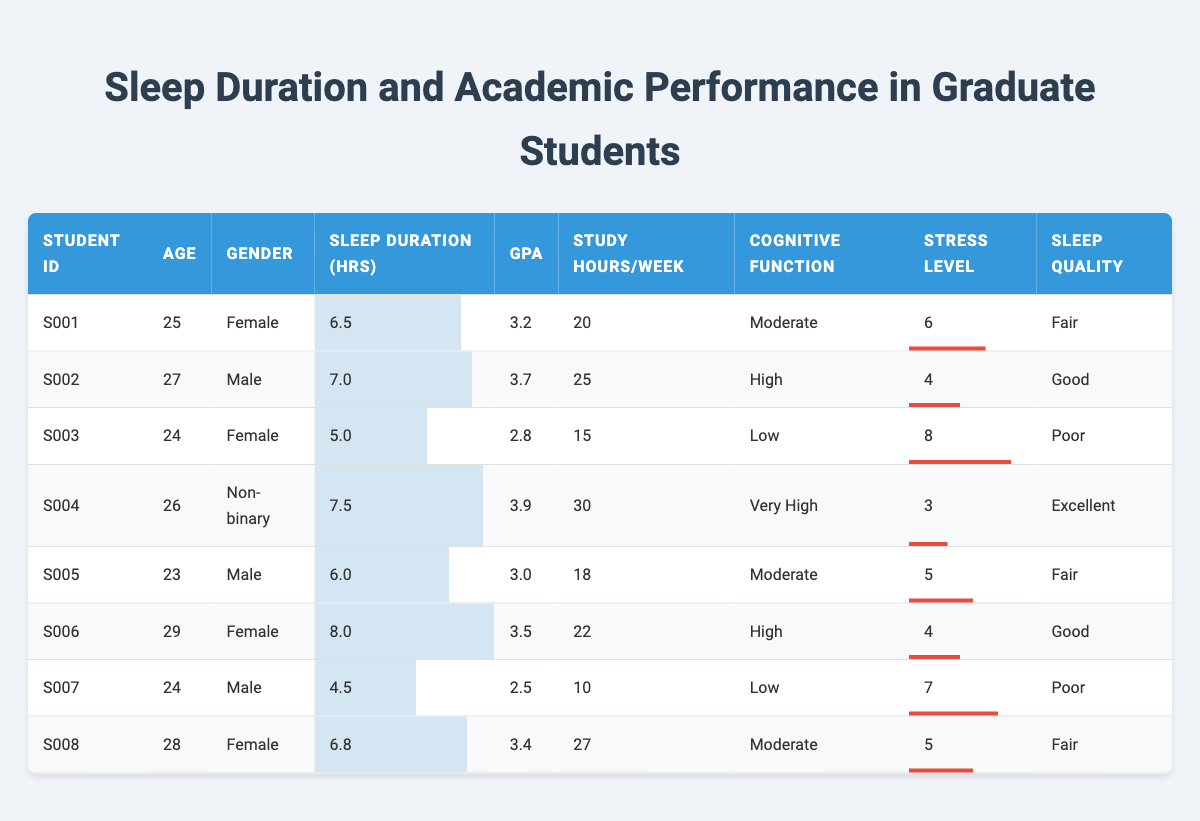What is the GPA of the student with the highest average sleep duration? The student with the highest average sleep duration is S006, who sleeps 8.0 hours and has a GPA of 3.5.
Answer: 3.5 How many students have a GPA above 3.5? The students with a GPA above 3.5 are S002, S004, and S006, totaling 3 students.
Answer: 3 What is the average age of all students in the table? The total ages of all students are 25 + 27 + 24 + 26 + 23 + 29 + 24 + 28 = 206. There are 8 students, so the average age is 206/8 = 25.75.
Answer: 25.75 Is there a student who sleeps less than 5 hours on average? Yes, student S007 sleeps an average of 4.5 hours, which is less than 5 hours.
Answer: Yes What is the difference between the highest and lowest GPA in the table? The highest GPA is 3.9 (S004) and the lowest GPA is 2.5 (S007). The difference is 3.9 - 2.5 = 1.4.
Answer: 1.4 How many students reported "Low" cognitive function? The students who reported "Low" cognitive function are S003 and S007, so there are 2 in total.
Answer: 2 What is the average sleep duration of students who have "Good" sleep quality? The average sleep duration of students with "Good" sleep quality (S002, S006) is calculated as (7.0 + 8.0) / 2 = 7.5 hours.
Answer: 7.5 Which student has the lowest stress level, and what is that level? The student with the lowest stress level is S004, with a stress level of 3.
Answer: 3 How many students have a stress level of 6 or above? The students with a stress level of 6 or above are S001, S003, S007, totaling 3 students.
Answer: 3 What percentage of students have a GPA below 3.0? The students with a GPA below 3.0 are S003 and S007, which is 2 out of 8 students. The percentage is (2/8) * 100 = 25%.
Answer: 25% 